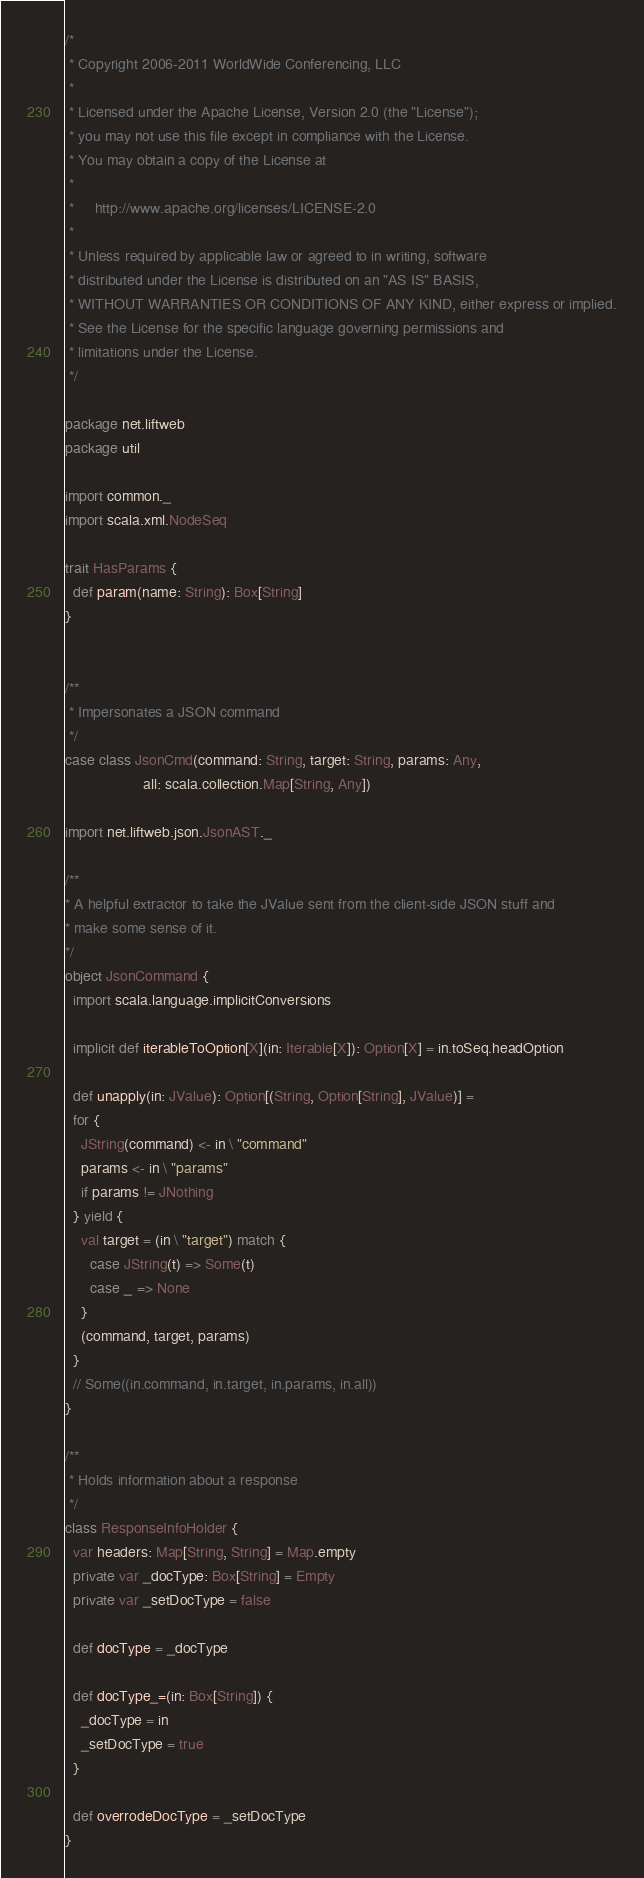<code> <loc_0><loc_0><loc_500><loc_500><_Scala_>/*
 * Copyright 2006-2011 WorldWide Conferencing, LLC
 *
 * Licensed under the Apache License, Version 2.0 (the "License");
 * you may not use this file except in compliance with the License.
 * You may obtain a copy of the License at
 *
 *     http://www.apache.org/licenses/LICENSE-2.0
 *
 * Unless required by applicable law or agreed to in writing, software
 * distributed under the License is distributed on an "AS IS" BASIS,
 * WITHOUT WARRANTIES OR CONDITIONS OF ANY KIND, either express or implied.
 * See the License for the specific language governing permissions and
 * limitations under the License.
 */

package net.liftweb
package util

import common._
import scala.xml.NodeSeq

trait HasParams {
  def param(name: String): Box[String]
}


/**
 * Impersonates a JSON command
 */
case class JsonCmd(command: String, target: String, params: Any,
                   all: scala.collection.Map[String, Any])

import net.liftweb.json.JsonAST._

/**
* A helpful extractor to take the JValue sent from the client-side JSON stuff and
* make some sense of it.
*/
object JsonCommand {
  import scala.language.implicitConversions

  implicit def iterableToOption[X](in: Iterable[X]): Option[X] = in.toSeq.headOption

  def unapply(in: JValue): Option[(String, Option[String], JValue)] =
  for {
    JString(command) <- in \ "command"
    params <- in \ "params"
    if params != JNothing
  } yield {
    val target = (in \ "target") match {
      case JString(t) => Some(t)
      case _ => None
    }
    (command, target, params)
  }
  // Some((in.command, in.target, in.params, in.all))
}

/**
 * Holds information about a response
 */
class ResponseInfoHolder {
  var headers: Map[String, String] = Map.empty
  private var _docType: Box[String] = Empty
  private var _setDocType = false

  def docType = _docType

  def docType_=(in: Box[String]) {
    _docType = in
    _setDocType = true
  }

  def overrodeDocType = _setDocType
}
</code> 